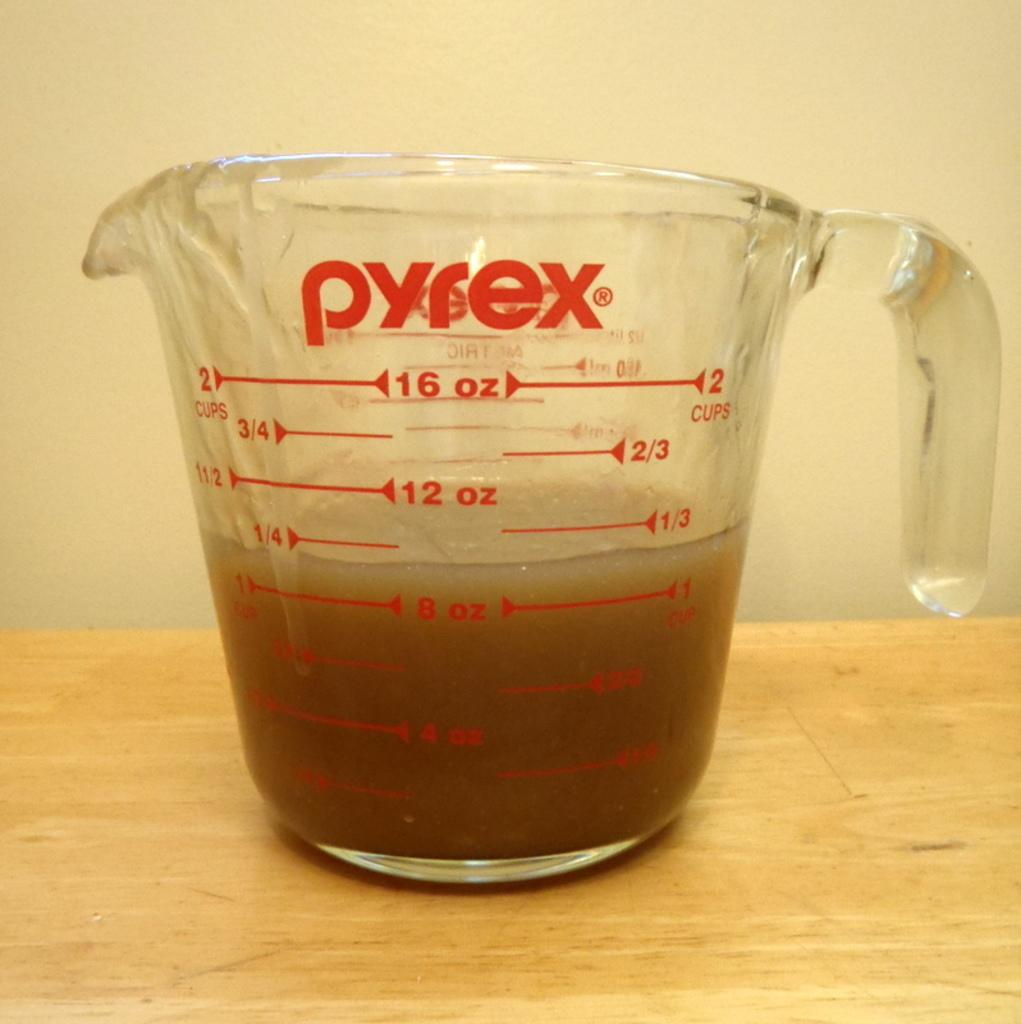<image>
Create a compact narrative representing the image presented. A measuring cup made by Pyrex that is half full. 